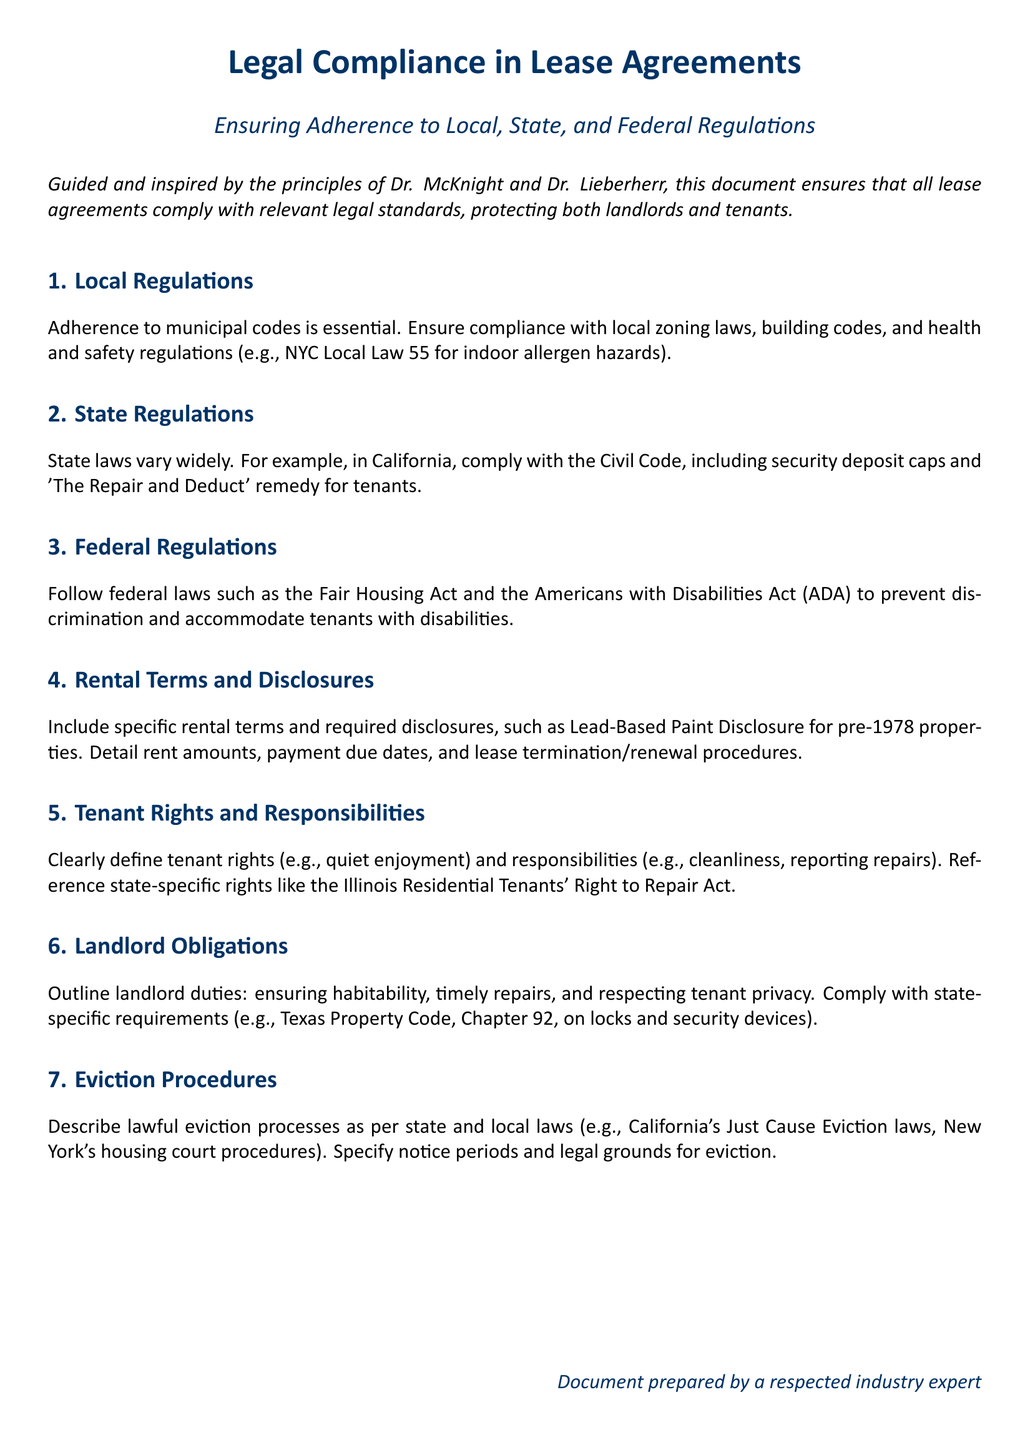What are the local regulations mentioned? The section specifies that local regulations include compliance with municipal codes, zoning laws, building codes, and health and safety regulations.
Answer: municipal codes, zoning laws, building codes, health and safety regulations What specific state law is referenced for California? The document highlights compliance with the California Civil Code regarding security deposits and tenant remedies.
Answer: Civil Code What federal laws must be followed according to the document? The document mentions the Fair Housing Act and the Americans with Disabilities Act as key federal laws.
Answer: Fair Housing Act, Americans with Disabilities Act What is required for pre-1978 properties? A specific disclosure is mandated for properties built before 1978 to inform tenants of lead-based paint hazards.
Answer: Lead-Based Paint Disclosure What tenant right is discussed in relation to Illinois? The document references the Illinois Residential Tenants' Right to Repair Act as a specific tenant right.
Answer: Illinois Residential Tenants' Right to Repair Act What must be outlined as landlord obligations? Landlord obligations discussed include ensuring habitability, timely repairs, and respecting tenant privacy.
Answer: ensuring habitability, timely repairs, respecting tenant privacy What does the document describe regarding eviction procedures? The document outlines the lawful eviction processes that must adhere to state and local laws.
Answer: lawful eviction processes What specific California law is mentioned regarding eviction? The document references California's Just Cause Eviction laws in relation to eviction procedures.
Answer: Just Cause Eviction laws 